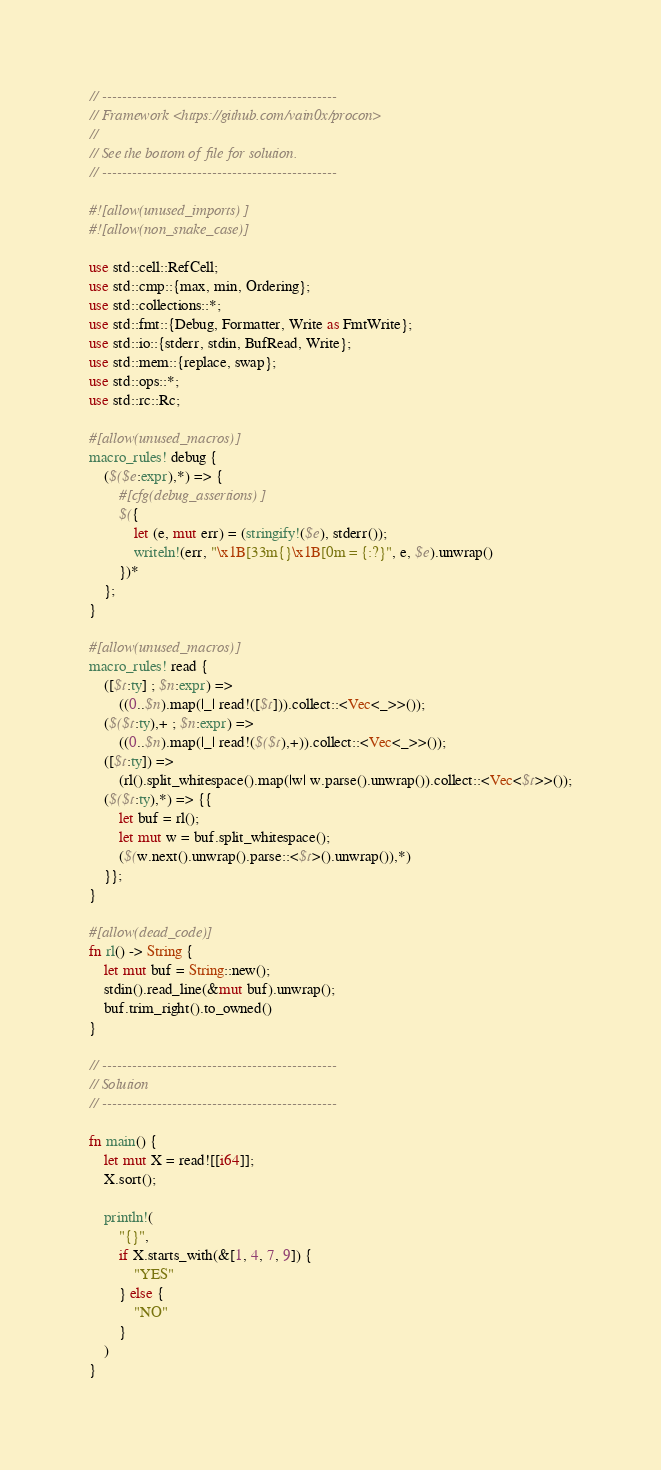<code> <loc_0><loc_0><loc_500><loc_500><_Rust_>// -----------------------------------------------
// Framework <https://github.com/vain0x/procon>
//
// See the bottom of file for solution.
// -----------------------------------------------

#![allow(unused_imports)]
#![allow(non_snake_case)]

use std::cell::RefCell;
use std::cmp::{max, min, Ordering};
use std::collections::*;
use std::fmt::{Debug, Formatter, Write as FmtWrite};
use std::io::{stderr, stdin, BufRead, Write};
use std::mem::{replace, swap};
use std::ops::*;
use std::rc::Rc;

#[allow(unused_macros)]
macro_rules! debug {
    ($($e:expr),*) => {
        #[cfg(debug_assertions)]
        $({
            let (e, mut err) = (stringify!($e), stderr());
            writeln!(err, "\x1B[33m{}\x1B[0m = {:?}", e, $e).unwrap()
        })*
    };
}

#[allow(unused_macros)]
macro_rules! read {
    ([$t:ty] ; $n:expr) =>
        ((0..$n).map(|_| read!([$t])).collect::<Vec<_>>());
    ($($t:ty),+ ; $n:expr) =>
        ((0..$n).map(|_| read!($($t),+)).collect::<Vec<_>>());
    ([$t:ty]) =>
        (rl().split_whitespace().map(|w| w.parse().unwrap()).collect::<Vec<$t>>());
    ($($t:ty),*) => {{
        let buf = rl();
        let mut w = buf.split_whitespace();
        ($(w.next().unwrap().parse::<$t>().unwrap()),*)
    }};
}

#[allow(dead_code)]
fn rl() -> String {
    let mut buf = String::new();
    stdin().read_line(&mut buf).unwrap();
    buf.trim_right().to_owned()
}

// -----------------------------------------------
// Solution
// -----------------------------------------------

fn main() {
    let mut X = read![[i64]];
    X.sort();

    println!(
        "{}",
        if X.starts_with(&[1, 4, 7, 9]) {
            "YES"
        } else {
            "NO"
        }
    )
}
</code> 